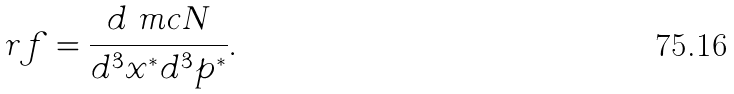<formula> <loc_0><loc_0><loc_500><loc_500>r f = \frac { d \ m c { N } } { d ^ { 3 } x ^ { * } d ^ { 3 } p ^ { * } } .</formula> 